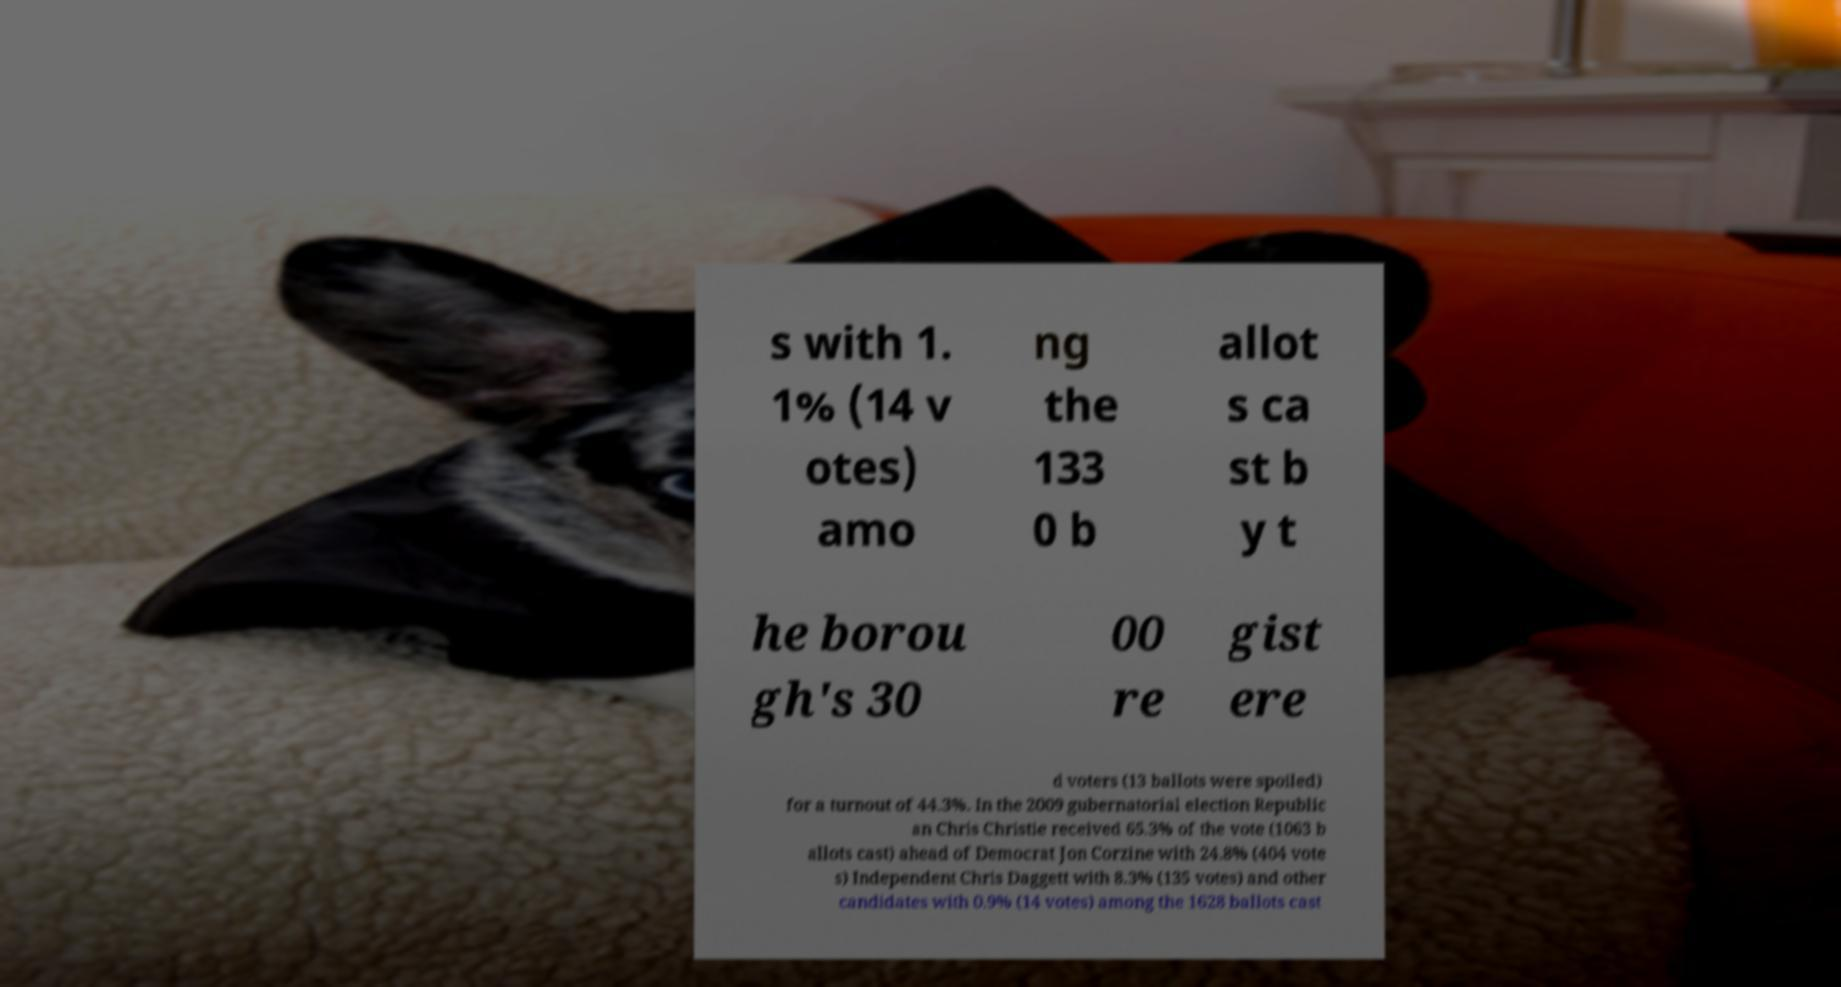Please read and relay the text visible in this image. What does it say? s with 1. 1% (14 v otes) amo ng the 133 0 b allot s ca st b y t he borou gh's 30 00 re gist ere d voters (13 ballots were spoiled) for a turnout of 44.3%. In the 2009 gubernatorial election Republic an Chris Christie received 65.3% of the vote (1063 b allots cast) ahead of Democrat Jon Corzine with 24.8% (404 vote s) Independent Chris Daggett with 8.3% (135 votes) and other candidates with 0.9% (14 votes) among the 1628 ballots cast 